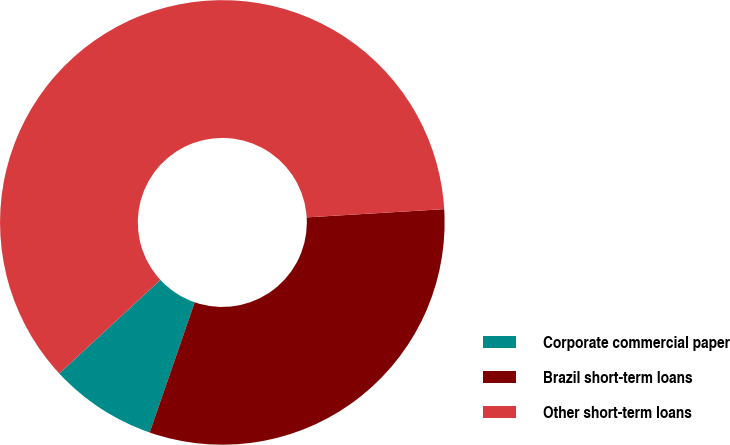<chart> <loc_0><loc_0><loc_500><loc_500><pie_chart><fcel>Corporate commercial paper<fcel>Brazil short-term loans<fcel>Other short-term loans<nl><fcel>7.81%<fcel>31.25%<fcel>60.94%<nl></chart> 